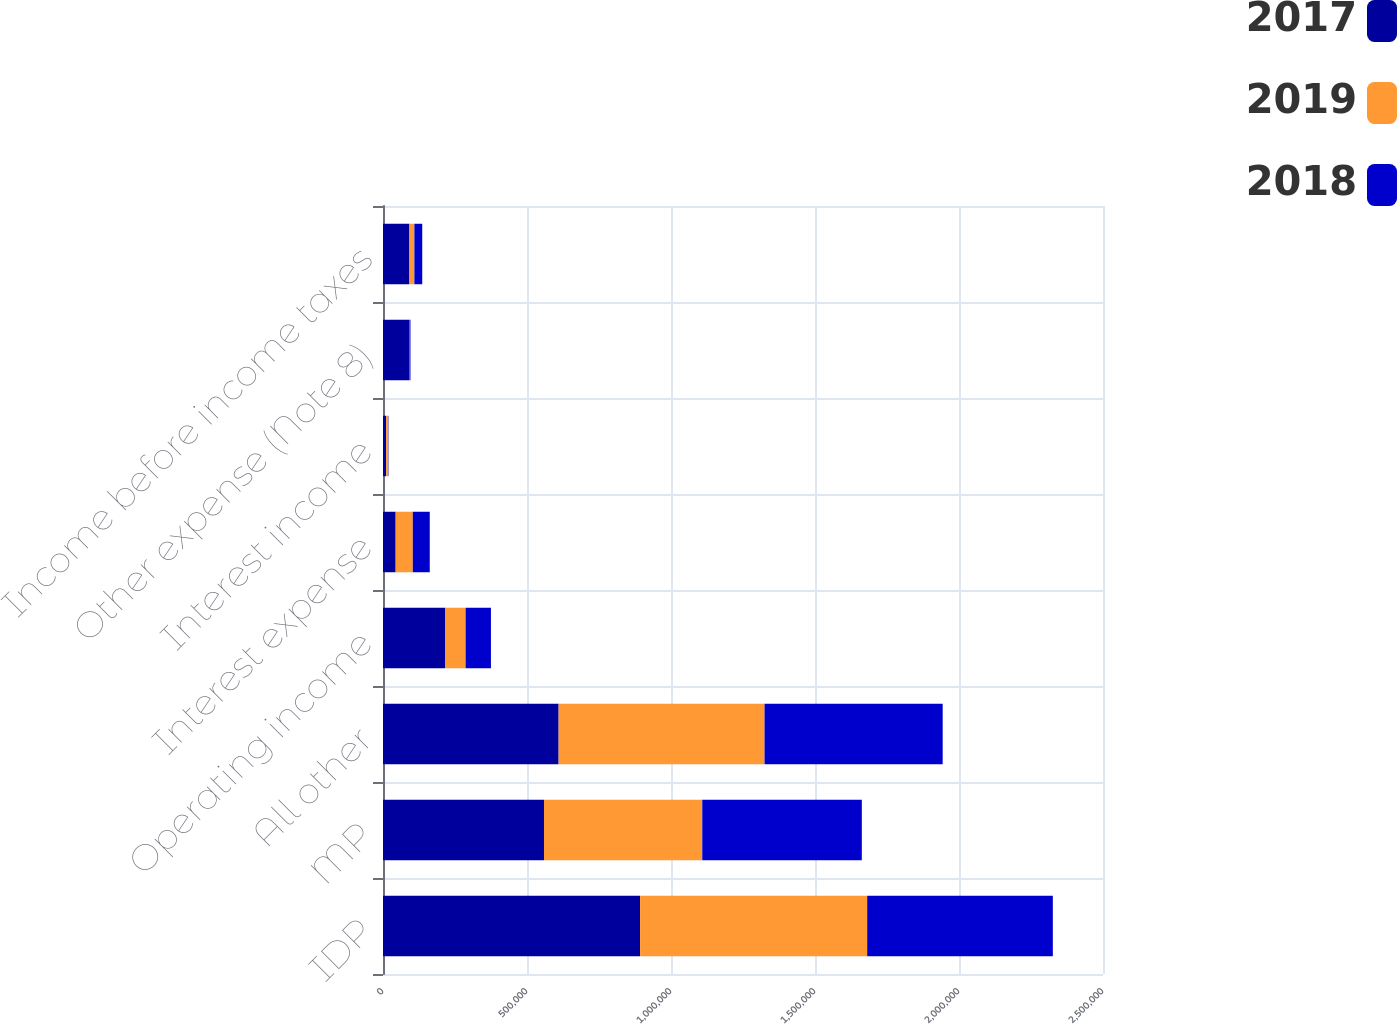Convert chart to OTSL. <chart><loc_0><loc_0><loc_500><loc_500><stacked_bar_chart><ecel><fcel>IDP<fcel>MP<fcel>All other<fcel>Operating income<fcel>Interest expense<fcel>Interest income<fcel>Other expense (Note 8)<fcel>Income before income taxes<nl><fcel>2017<fcel>892665<fcel>558990<fcel>609828<fcel>216466<fcel>43963<fcel>10971<fcel>91682<fcel>91792<nl><fcel>2019<fcel>788495<fcel>549574<fcel>715011<fcel>70282<fcel>59548<fcel>7017<fcel>606<fcel>17145<nl><fcel>2018<fcel>644653<fcel>554001<fcel>618481<fcel>88059<fcel>58879<fcel>1212<fcel>3087<fcel>27305<nl></chart> 